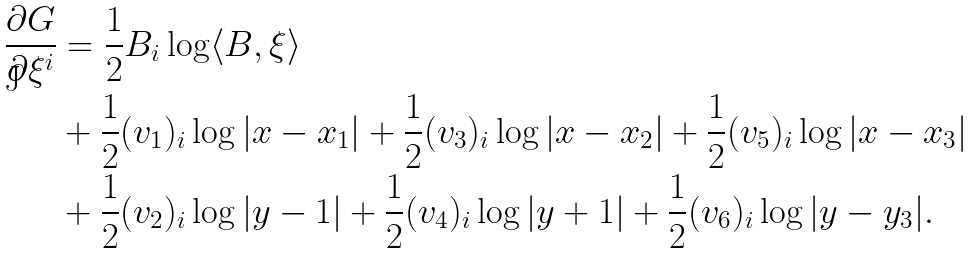<formula> <loc_0><loc_0><loc_500><loc_500>\frac { \partial G } { \partial \xi ^ { i } } & = \frac { 1 } { 2 } B _ { i } \log \langle B , \xi \rangle \\ & + \frac { 1 } { 2 } ( v _ { 1 } ) _ { i } \log | x - x _ { 1 } | + \frac { 1 } { 2 } ( v _ { 3 } ) _ { i } \log | x - x _ { 2 } | + \frac { 1 } { 2 } ( v _ { 5 } ) _ { i } \log | x - x _ { 3 } | \\ & + \frac { 1 } { 2 } ( v _ { 2 } ) _ { i } \log | y - 1 | + \frac { 1 } { 2 } ( v _ { 4 } ) _ { i } \log | y + 1 | + \frac { 1 } { 2 } ( v _ { 6 } ) _ { i } \log | y - y _ { 3 } | .</formula> 